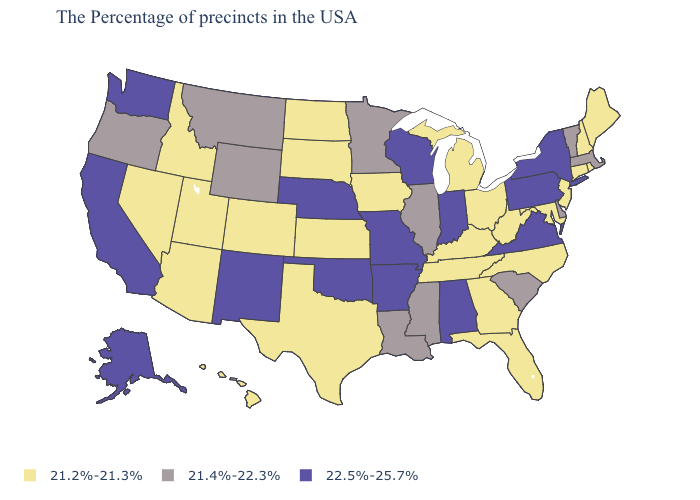What is the lowest value in the MidWest?
Keep it brief. 21.2%-21.3%. What is the highest value in the USA?
Give a very brief answer. 22.5%-25.7%. Among the states that border Louisiana , does Arkansas have the highest value?
Short answer required. Yes. Does the first symbol in the legend represent the smallest category?
Short answer required. Yes. Is the legend a continuous bar?
Concise answer only. No. Is the legend a continuous bar?
Concise answer only. No. What is the value of Minnesota?
Quick response, please. 21.4%-22.3%. Does Arkansas have a higher value than Massachusetts?
Short answer required. Yes. Name the states that have a value in the range 21.4%-22.3%?
Quick response, please. Massachusetts, Vermont, Delaware, South Carolina, Illinois, Mississippi, Louisiana, Minnesota, Wyoming, Montana, Oregon. Does the first symbol in the legend represent the smallest category?
Answer briefly. Yes. Name the states that have a value in the range 21.4%-22.3%?
Short answer required. Massachusetts, Vermont, Delaware, South Carolina, Illinois, Mississippi, Louisiana, Minnesota, Wyoming, Montana, Oregon. What is the value of Missouri?
Concise answer only. 22.5%-25.7%. Name the states that have a value in the range 22.5%-25.7%?
Concise answer only. New York, Pennsylvania, Virginia, Indiana, Alabama, Wisconsin, Missouri, Arkansas, Nebraska, Oklahoma, New Mexico, California, Washington, Alaska. Among the states that border Arkansas , does Tennessee have the highest value?
Answer briefly. No. Among the states that border Maine , which have the lowest value?
Quick response, please. New Hampshire. 